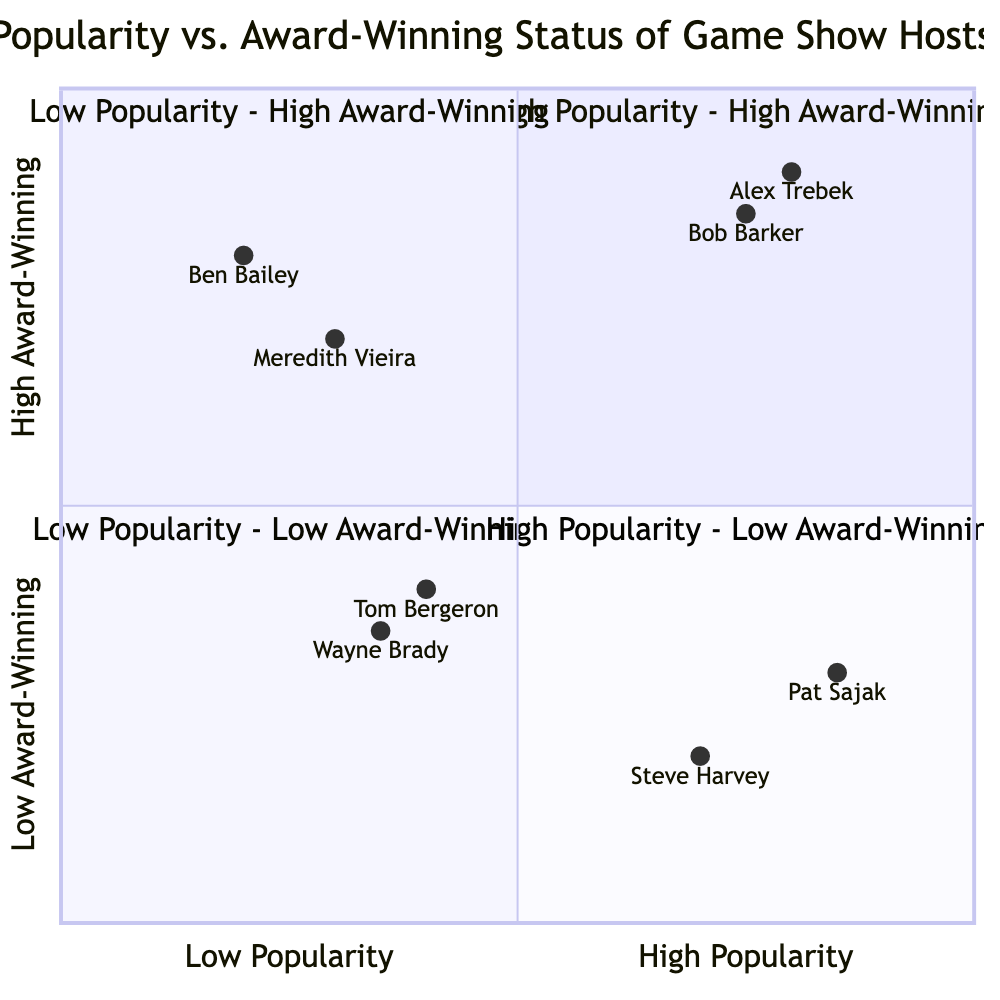What hosts are in the High Popularity - High Award-Winning quadrant? The question asks for the names of the hosts located in the quadrant representing both high popularity and high award-winning status. By examining the diagram, we find Alex Trebek and Bob Barker positioned in this quadrant.
Answer: Alex Trebek, Bob Barker Which host has low popularity but high award-winning status? This question seeks the name of the host who occupies the quadrant with low popularity and high award-winning status. Upon reviewing the diagram, we see Meredith Vieira and Ben Bailey in this quadrant, but only one name is needed.
Answer: Meredith Vieira How many hosts are in the Low Popularity - Low Award-Winning quadrant? The question requests the count of hosts placed in the quadrant characterized by both low popularity and low award-winning status. By checking the diagram, we notice two hosts, Tom Bergeron and Wayne Brady, in this quadrant. Thus, the answer is simply the number of names.
Answer: 2 What is the relationship between Pat Sajak and Steve Harvey in terms of popularity and award-winning status? To answer this question, we compare the positions of Pat Sajak and Steve Harvey. Both are located in the High Popularity - Low Award-Winning quadrant, indicating they share a similarity: high popularity but fewer awards. Therefore, their relationship can be described as having the same level of popularity but differing award statuses.
Answer: Same quadrant Which quadrant contains the highest number of award-winning hosts? This question assesses the quadrants to identify where the most hosts with high award-winning status are located. The High Popularity - High Award-Winning quadrant shows 2 hosts, and the Low Popularity - High Award-Winning quadrant shows 2 hosts as well. Hence, it is determined that there is no single quadrant with more hosts than the others with high award-winning status.
Answer: None Which host is the least popular? This question inquires about the host who ranks lowest in popularity. Evaluating the diagram, Ben Bailey is situated in the Low Popularity - High Award-Winning quadrant and has the lowest popularity measurement compared to others listed in our quadrants.
Answer: Ben Bailey What is the axis representing award-winning status? The axis in question is the vertical axis of the diagram, which illustrates the transition from low award-winning status at the bottom to high award-winning status at the top. Observing the diagram confirms this structure, making it clear that the y-axis reflects the award-winning status.
Answer: Y-axis Where do hosts with both high popularity and low awards fall? The question looks for the specific quadrant that hosts with high popularity but are not many-time winners belong to. From the diagram, we see that Pat Sajak and Steve Harvey are the hosts fitting this description, placing them in the quadrant labeled High Popularity - Low Award-Winning.
Answer: High Popularity - Low Award-Winning Which host is neither popular nor award-winning? This question focuses on identifying a host that falls within both the low popularity and low award-winning categories. Analyzing the diagram positions Tom Bergeron and Wayne Brady in the Low Popularity - Low Award-Winning quadrant, but only one name is required.
Answer: Tom Bergeron 